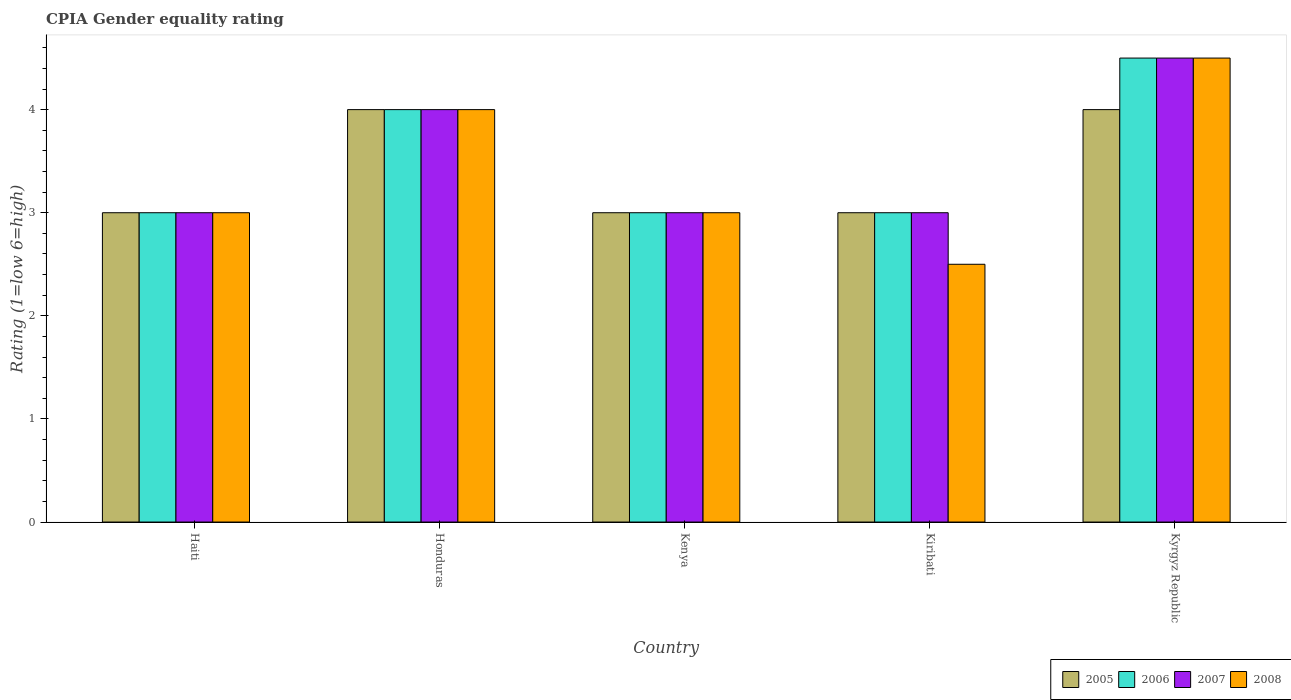Are the number of bars per tick equal to the number of legend labels?
Give a very brief answer. Yes. How many bars are there on the 3rd tick from the left?
Offer a terse response. 4. What is the label of the 5th group of bars from the left?
Your answer should be very brief. Kyrgyz Republic. What is the CPIA rating in 2007 in Honduras?
Offer a very short reply. 4. Across all countries, what is the minimum CPIA rating in 2008?
Keep it short and to the point. 2.5. In which country was the CPIA rating in 2007 maximum?
Your answer should be very brief. Kyrgyz Republic. In which country was the CPIA rating in 2007 minimum?
Make the answer very short. Haiti. What is the difference between the CPIA rating in 2007 in Haiti and that in Kiribati?
Offer a very short reply. 0. What is the difference between the CPIA rating in 2005 in Kenya and the CPIA rating in 2006 in Kiribati?
Provide a succinct answer. 0. What is the difference between the CPIA rating of/in 2005 and CPIA rating of/in 2006 in Honduras?
Give a very brief answer. 0. In how many countries, is the CPIA rating in 2007 greater than 4?
Give a very brief answer. 1. What is the ratio of the CPIA rating in 2005 in Honduras to that in Kiribati?
Offer a very short reply. 1.33. Is the CPIA rating in 2005 in Honduras less than that in Kyrgyz Republic?
Make the answer very short. No. Is the difference between the CPIA rating in 2005 in Honduras and Kenya greater than the difference between the CPIA rating in 2006 in Honduras and Kenya?
Provide a succinct answer. No. Is the sum of the CPIA rating in 2006 in Haiti and Kiribati greater than the maximum CPIA rating in 2005 across all countries?
Give a very brief answer. Yes. Is it the case that in every country, the sum of the CPIA rating in 2008 and CPIA rating in 2006 is greater than the sum of CPIA rating in 2007 and CPIA rating in 2005?
Provide a succinct answer. No. How many bars are there?
Your response must be concise. 20. Are all the bars in the graph horizontal?
Ensure brevity in your answer.  No. Does the graph contain any zero values?
Offer a terse response. No. Does the graph contain grids?
Your response must be concise. No. How many legend labels are there?
Offer a terse response. 4. What is the title of the graph?
Your answer should be compact. CPIA Gender equality rating. What is the label or title of the X-axis?
Keep it short and to the point. Country. What is the Rating (1=low 6=high) of 2006 in Haiti?
Give a very brief answer. 3. What is the Rating (1=low 6=high) in 2007 in Haiti?
Keep it short and to the point. 3. What is the Rating (1=low 6=high) in 2005 in Honduras?
Your answer should be very brief. 4. What is the Rating (1=low 6=high) of 2005 in Kenya?
Provide a succinct answer. 3. What is the Rating (1=low 6=high) of 2006 in Kenya?
Make the answer very short. 3. What is the Rating (1=low 6=high) of 2008 in Kenya?
Make the answer very short. 3. What is the Rating (1=low 6=high) of 2005 in Kyrgyz Republic?
Make the answer very short. 4. What is the Rating (1=low 6=high) in 2006 in Kyrgyz Republic?
Your answer should be very brief. 4.5. What is the Rating (1=low 6=high) in 2007 in Kyrgyz Republic?
Your answer should be compact. 4.5. Across all countries, what is the maximum Rating (1=low 6=high) in 2005?
Your answer should be very brief. 4. Across all countries, what is the maximum Rating (1=low 6=high) of 2006?
Ensure brevity in your answer.  4.5. Across all countries, what is the maximum Rating (1=low 6=high) in 2007?
Offer a terse response. 4.5. Across all countries, what is the minimum Rating (1=low 6=high) of 2005?
Your answer should be compact. 3. What is the total Rating (1=low 6=high) in 2006 in the graph?
Provide a short and direct response. 17.5. What is the total Rating (1=low 6=high) of 2008 in the graph?
Offer a very short reply. 17. What is the difference between the Rating (1=low 6=high) of 2008 in Haiti and that in Honduras?
Your response must be concise. -1. What is the difference between the Rating (1=low 6=high) in 2007 in Haiti and that in Kenya?
Your answer should be very brief. 0. What is the difference between the Rating (1=low 6=high) in 2008 in Haiti and that in Kenya?
Your answer should be compact. 0. What is the difference between the Rating (1=low 6=high) in 2005 in Haiti and that in Kiribati?
Provide a short and direct response. 0. What is the difference between the Rating (1=low 6=high) of 2008 in Haiti and that in Kiribati?
Your answer should be compact. 0.5. What is the difference between the Rating (1=low 6=high) in 2006 in Haiti and that in Kyrgyz Republic?
Offer a very short reply. -1.5. What is the difference between the Rating (1=low 6=high) in 2007 in Haiti and that in Kyrgyz Republic?
Offer a very short reply. -1.5. What is the difference between the Rating (1=low 6=high) in 2008 in Haiti and that in Kyrgyz Republic?
Your response must be concise. -1.5. What is the difference between the Rating (1=low 6=high) of 2005 in Honduras and that in Kenya?
Your answer should be compact. 1. What is the difference between the Rating (1=low 6=high) of 2006 in Honduras and that in Kenya?
Your answer should be compact. 1. What is the difference between the Rating (1=low 6=high) of 2005 in Honduras and that in Kiribati?
Keep it short and to the point. 1. What is the difference between the Rating (1=low 6=high) in 2006 in Honduras and that in Kiribati?
Make the answer very short. 1. What is the difference between the Rating (1=low 6=high) in 2008 in Honduras and that in Kiribati?
Give a very brief answer. 1.5. What is the difference between the Rating (1=low 6=high) in 2005 in Honduras and that in Kyrgyz Republic?
Offer a terse response. 0. What is the difference between the Rating (1=low 6=high) in 2006 in Honduras and that in Kyrgyz Republic?
Your answer should be very brief. -0.5. What is the difference between the Rating (1=low 6=high) in 2008 in Kenya and that in Kyrgyz Republic?
Offer a very short reply. -1.5. What is the difference between the Rating (1=low 6=high) of 2006 in Kiribati and that in Kyrgyz Republic?
Keep it short and to the point. -1.5. What is the difference between the Rating (1=low 6=high) of 2008 in Kiribati and that in Kyrgyz Republic?
Keep it short and to the point. -2. What is the difference between the Rating (1=low 6=high) of 2005 in Haiti and the Rating (1=low 6=high) of 2008 in Honduras?
Offer a terse response. -1. What is the difference between the Rating (1=low 6=high) in 2006 in Haiti and the Rating (1=low 6=high) in 2007 in Honduras?
Offer a very short reply. -1. What is the difference between the Rating (1=low 6=high) in 2006 in Haiti and the Rating (1=low 6=high) in 2008 in Honduras?
Make the answer very short. -1. What is the difference between the Rating (1=low 6=high) of 2007 in Haiti and the Rating (1=low 6=high) of 2008 in Honduras?
Give a very brief answer. -1. What is the difference between the Rating (1=low 6=high) of 2005 in Haiti and the Rating (1=low 6=high) of 2006 in Kenya?
Give a very brief answer. 0. What is the difference between the Rating (1=low 6=high) of 2007 in Haiti and the Rating (1=low 6=high) of 2008 in Kenya?
Offer a very short reply. 0. What is the difference between the Rating (1=low 6=high) in 2005 in Haiti and the Rating (1=low 6=high) in 2006 in Kiribati?
Ensure brevity in your answer.  0. What is the difference between the Rating (1=low 6=high) in 2005 in Haiti and the Rating (1=low 6=high) in 2007 in Kiribati?
Your answer should be very brief. 0. What is the difference between the Rating (1=low 6=high) of 2006 in Haiti and the Rating (1=low 6=high) of 2008 in Kiribati?
Give a very brief answer. 0.5. What is the difference between the Rating (1=low 6=high) of 2005 in Haiti and the Rating (1=low 6=high) of 2007 in Kyrgyz Republic?
Your answer should be compact. -1.5. What is the difference between the Rating (1=low 6=high) in 2006 in Haiti and the Rating (1=low 6=high) in 2008 in Kyrgyz Republic?
Your answer should be very brief. -1.5. What is the difference between the Rating (1=low 6=high) of 2005 in Honduras and the Rating (1=low 6=high) of 2006 in Kenya?
Your answer should be compact. 1. What is the difference between the Rating (1=low 6=high) in 2005 in Honduras and the Rating (1=low 6=high) in 2007 in Kenya?
Your answer should be compact. 1. What is the difference between the Rating (1=low 6=high) in 2005 in Honduras and the Rating (1=low 6=high) in 2008 in Kenya?
Ensure brevity in your answer.  1. What is the difference between the Rating (1=low 6=high) of 2006 in Honduras and the Rating (1=low 6=high) of 2007 in Kenya?
Offer a very short reply. 1. What is the difference between the Rating (1=low 6=high) in 2006 in Honduras and the Rating (1=low 6=high) in 2008 in Kenya?
Ensure brevity in your answer.  1. What is the difference between the Rating (1=low 6=high) in 2007 in Honduras and the Rating (1=low 6=high) in 2008 in Kenya?
Give a very brief answer. 1. What is the difference between the Rating (1=low 6=high) of 2005 in Honduras and the Rating (1=low 6=high) of 2006 in Kiribati?
Make the answer very short. 1. What is the difference between the Rating (1=low 6=high) of 2005 in Honduras and the Rating (1=low 6=high) of 2007 in Kiribati?
Offer a very short reply. 1. What is the difference between the Rating (1=low 6=high) of 2005 in Honduras and the Rating (1=low 6=high) of 2008 in Kiribati?
Keep it short and to the point. 1.5. What is the difference between the Rating (1=low 6=high) of 2006 in Honduras and the Rating (1=low 6=high) of 2008 in Kiribati?
Your response must be concise. 1.5. What is the difference between the Rating (1=low 6=high) of 2005 in Honduras and the Rating (1=low 6=high) of 2006 in Kyrgyz Republic?
Ensure brevity in your answer.  -0.5. What is the difference between the Rating (1=low 6=high) of 2007 in Honduras and the Rating (1=low 6=high) of 2008 in Kyrgyz Republic?
Offer a very short reply. -0.5. What is the difference between the Rating (1=low 6=high) in 2005 in Kenya and the Rating (1=low 6=high) in 2008 in Kiribati?
Make the answer very short. 0.5. What is the difference between the Rating (1=low 6=high) of 2005 in Kenya and the Rating (1=low 6=high) of 2006 in Kyrgyz Republic?
Ensure brevity in your answer.  -1.5. What is the difference between the Rating (1=low 6=high) in 2007 in Kenya and the Rating (1=low 6=high) in 2008 in Kyrgyz Republic?
Give a very brief answer. -1.5. What is the difference between the Rating (1=low 6=high) in 2005 in Kiribati and the Rating (1=low 6=high) in 2006 in Kyrgyz Republic?
Offer a very short reply. -1.5. What is the difference between the Rating (1=low 6=high) in 2005 in Kiribati and the Rating (1=low 6=high) in 2008 in Kyrgyz Republic?
Ensure brevity in your answer.  -1.5. What is the difference between the Rating (1=low 6=high) of 2006 in Kiribati and the Rating (1=low 6=high) of 2007 in Kyrgyz Republic?
Your answer should be very brief. -1.5. What is the difference between the Rating (1=low 6=high) in 2006 in Kiribati and the Rating (1=low 6=high) in 2008 in Kyrgyz Republic?
Offer a terse response. -1.5. What is the average Rating (1=low 6=high) in 2006 per country?
Your answer should be compact. 3.5. What is the average Rating (1=low 6=high) in 2008 per country?
Ensure brevity in your answer.  3.4. What is the difference between the Rating (1=low 6=high) in 2005 and Rating (1=low 6=high) in 2008 in Haiti?
Provide a short and direct response. 0. What is the difference between the Rating (1=low 6=high) of 2006 and Rating (1=low 6=high) of 2008 in Haiti?
Your response must be concise. 0. What is the difference between the Rating (1=low 6=high) in 2005 and Rating (1=low 6=high) in 2006 in Honduras?
Your response must be concise. 0. What is the difference between the Rating (1=low 6=high) of 2005 and Rating (1=low 6=high) of 2008 in Honduras?
Give a very brief answer. 0. What is the difference between the Rating (1=low 6=high) in 2006 and Rating (1=low 6=high) in 2007 in Honduras?
Provide a succinct answer. 0. What is the difference between the Rating (1=low 6=high) of 2006 and Rating (1=low 6=high) of 2008 in Honduras?
Offer a terse response. 0. What is the difference between the Rating (1=low 6=high) in 2005 and Rating (1=low 6=high) in 2007 in Kenya?
Provide a short and direct response. 0. What is the difference between the Rating (1=low 6=high) of 2005 and Rating (1=low 6=high) of 2008 in Kenya?
Your answer should be compact. 0. What is the difference between the Rating (1=low 6=high) in 2006 and Rating (1=low 6=high) in 2008 in Kenya?
Ensure brevity in your answer.  0. What is the difference between the Rating (1=low 6=high) in 2005 and Rating (1=low 6=high) in 2007 in Kiribati?
Offer a terse response. 0. What is the difference between the Rating (1=low 6=high) in 2005 and Rating (1=low 6=high) in 2008 in Kiribati?
Offer a very short reply. 0.5. What is the difference between the Rating (1=low 6=high) in 2006 and Rating (1=low 6=high) in 2008 in Kiribati?
Provide a short and direct response. 0.5. What is the difference between the Rating (1=low 6=high) in 2007 and Rating (1=low 6=high) in 2008 in Kiribati?
Make the answer very short. 0.5. What is the difference between the Rating (1=low 6=high) in 2005 and Rating (1=low 6=high) in 2007 in Kyrgyz Republic?
Provide a succinct answer. -0.5. What is the ratio of the Rating (1=low 6=high) of 2005 in Haiti to that in Honduras?
Keep it short and to the point. 0.75. What is the ratio of the Rating (1=low 6=high) of 2008 in Haiti to that in Honduras?
Provide a short and direct response. 0.75. What is the ratio of the Rating (1=low 6=high) in 2006 in Haiti to that in Kenya?
Offer a very short reply. 1. What is the ratio of the Rating (1=low 6=high) of 2007 in Haiti to that in Kenya?
Provide a succinct answer. 1. What is the ratio of the Rating (1=low 6=high) of 2008 in Haiti to that in Kenya?
Your response must be concise. 1. What is the ratio of the Rating (1=low 6=high) in 2005 in Haiti to that in Kiribati?
Make the answer very short. 1. What is the ratio of the Rating (1=low 6=high) of 2006 in Haiti to that in Kiribati?
Provide a succinct answer. 1. What is the ratio of the Rating (1=low 6=high) of 2005 in Honduras to that in Kenya?
Your answer should be very brief. 1.33. What is the ratio of the Rating (1=low 6=high) in 2007 in Honduras to that in Kenya?
Offer a very short reply. 1.33. What is the ratio of the Rating (1=low 6=high) of 2008 in Honduras to that in Kenya?
Your answer should be very brief. 1.33. What is the ratio of the Rating (1=low 6=high) of 2005 in Honduras to that in Kiribati?
Your answer should be very brief. 1.33. What is the ratio of the Rating (1=low 6=high) in 2006 in Honduras to that in Kiribati?
Offer a very short reply. 1.33. What is the ratio of the Rating (1=low 6=high) in 2007 in Honduras to that in Kyrgyz Republic?
Your answer should be very brief. 0.89. What is the ratio of the Rating (1=low 6=high) in 2005 in Kenya to that in Kiribati?
Your answer should be very brief. 1. What is the ratio of the Rating (1=low 6=high) in 2006 in Kenya to that in Kiribati?
Make the answer very short. 1. What is the ratio of the Rating (1=low 6=high) in 2007 in Kenya to that in Kiribati?
Ensure brevity in your answer.  1. What is the ratio of the Rating (1=low 6=high) of 2008 in Kenya to that in Kiribati?
Offer a very short reply. 1.2. What is the ratio of the Rating (1=low 6=high) in 2005 in Kenya to that in Kyrgyz Republic?
Offer a very short reply. 0.75. What is the ratio of the Rating (1=low 6=high) in 2005 in Kiribati to that in Kyrgyz Republic?
Provide a short and direct response. 0.75. What is the ratio of the Rating (1=low 6=high) in 2008 in Kiribati to that in Kyrgyz Republic?
Your answer should be very brief. 0.56. What is the difference between the highest and the second highest Rating (1=low 6=high) in 2005?
Your response must be concise. 0. What is the difference between the highest and the second highest Rating (1=low 6=high) in 2007?
Offer a very short reply. 0.5. What is the difference between the highest and the second highest Rating (1=low 6=high) of 2008?
Your response must be concise. 0.5. What is the difference between the highest and the lowest Rating (1=low 6=high) in 2005?
Make the answer very short. 1. What is the difference between the highest and the lowest Rating (1=low 6=high) in 2008?
Provide a short and direct response. 2. 